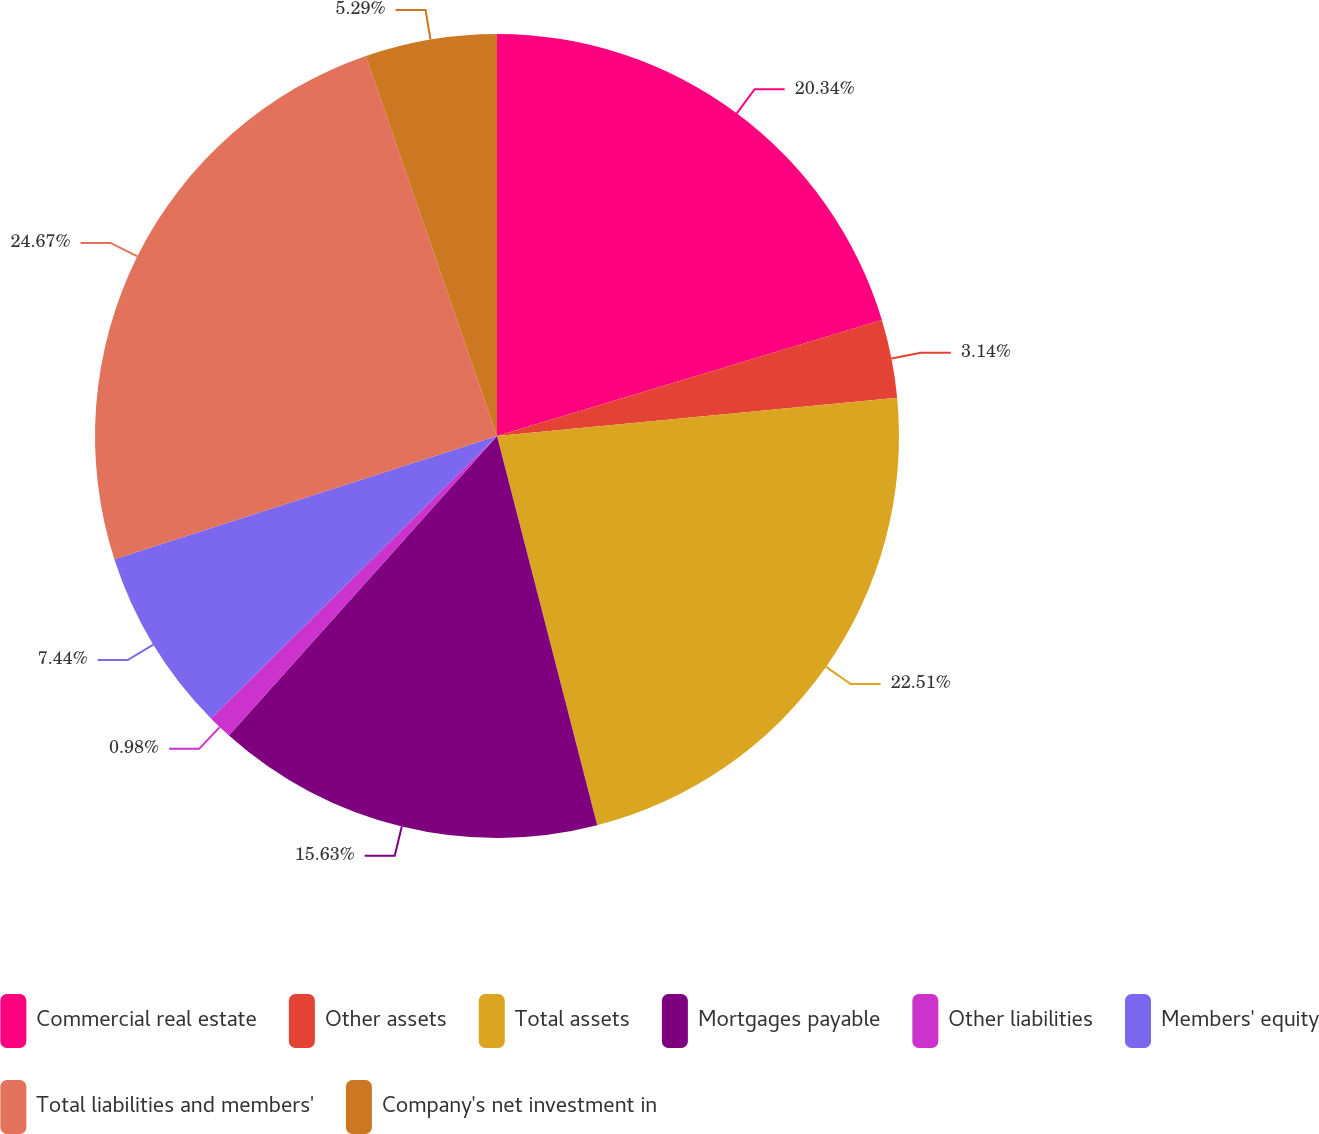Convert chart to OTSL. <chart><loc_0><loc_0><loc_500><loc_500><pie_chart><fcel>Commercial real estate<fcel>Other assets<fcel>Total assets<fcel>Mortgages payable<fcel>Other liabilities<fcel>Members' equity<fcel>Total liabilities and members'<fcel>Company's net investment in<nl><fcel>20.34%<fcel>3.14%<fcel>22.51%<fcel>15.63%<fcel>0.98%<fcel>7.44%<fcel>24.67%<fcel>5.29%<nl></chart> 